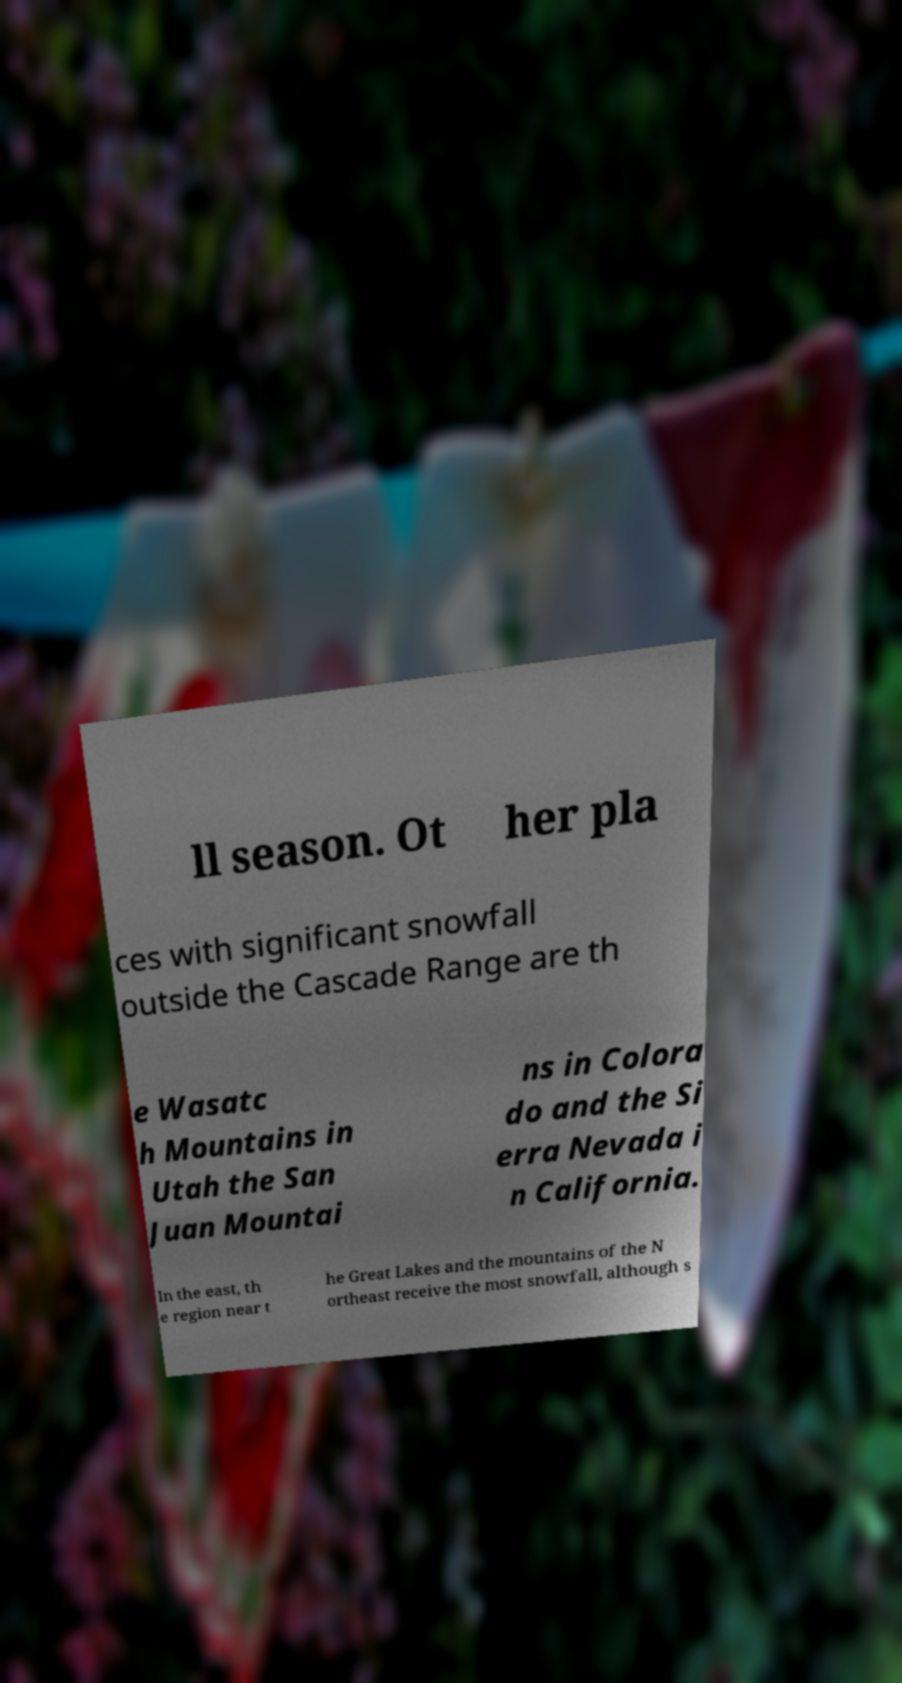I need the written content from this picture converted into text. Can you do that? ll season. Ot her pla ces with significant snowfall outside the Cascade Range are th e Wasatc h Mountains in Utah the San Juan Mountai ns in Colora do and the Si erra Nevada i n California. In the east, th e region near t he Great Lakes and the mountains of the N ortheast receive the most snowfall, although s 